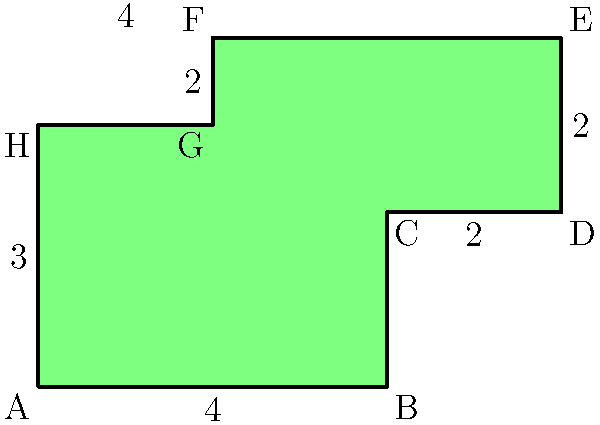As part of your successful graffiti reduction initiative, you've established a graffiti-free zone in the city center. The zone's shape is irregular, as shown in the diagram. Each small square represents 1 square unit. Calculate the total area of this graffiti-free zone. To calculate the area of this irregular shape, we'll divide it into rectangles and then add their areas:

1. The shape can be divided into three rectangles:
   a. Bottom rectangle: $4 \times 2 = 8$ square units
   b. Top-left rectangle: $2 \times 1 = 2$ square units
   c. Top-right rectangle: $4 \times 2 = 8$ square units

2. Add the areas of these rectangles:
   $\text{Total Area} = 8 + 2 + 8 = 18$ square units

Therefore, the total area of the graffiti-free zone is 18 square units.
Answer: 18 square units 